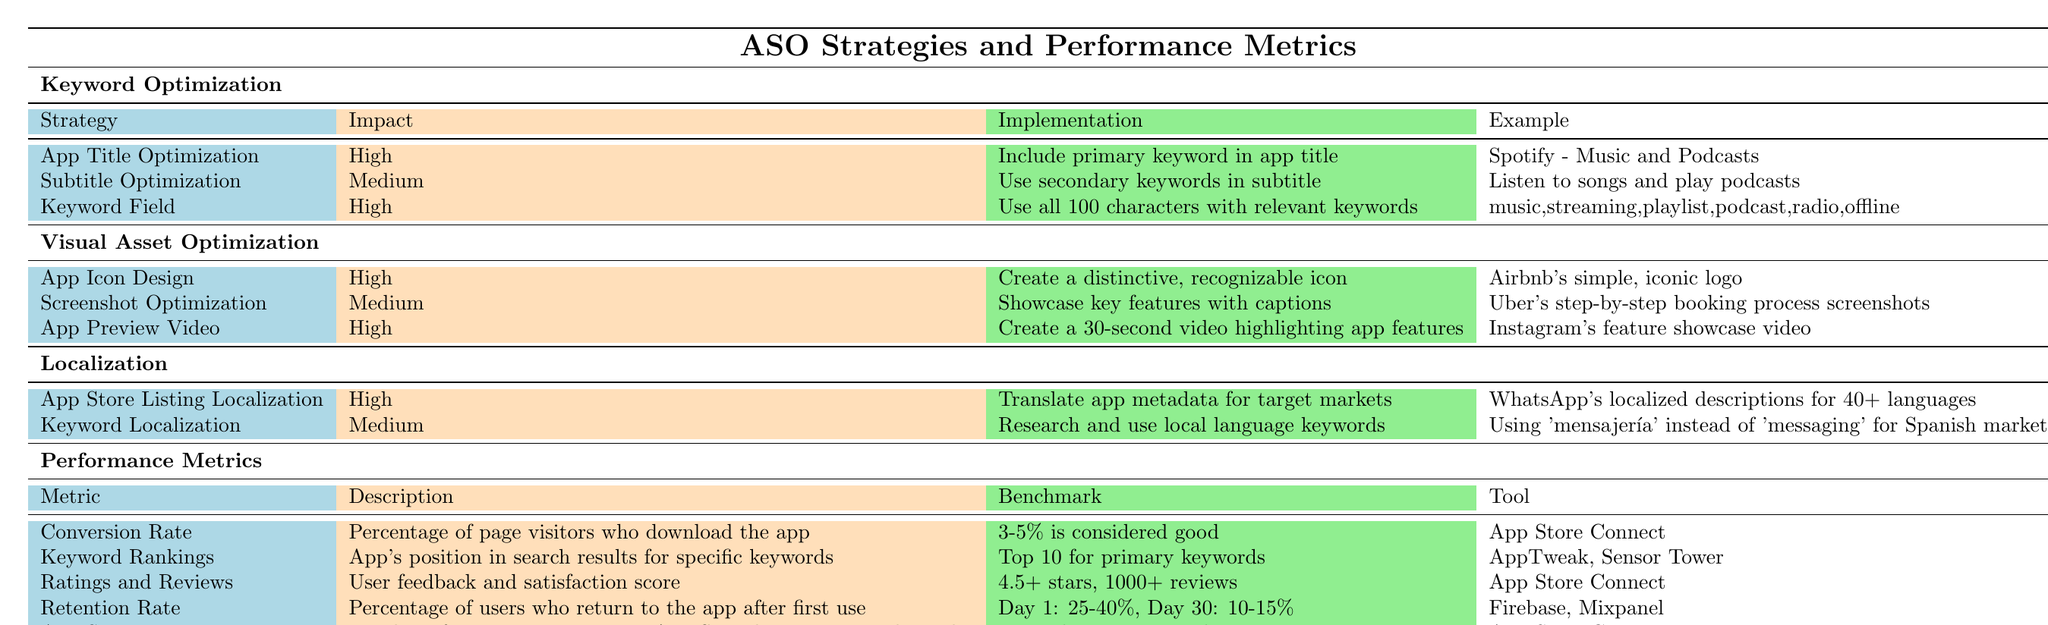What is the impact level of the "App Title Optimization" strategy? In the table, under the "Keyword Optimization" category, the row for "App Title Optimization" indicates that its impact is classified as "High."
Answer: High How many strategies are listed under the "Visual Asset Optimization" category? Looking at the "Visual Asset Optimization" category, there are three strategies mentioned: "App Icon Design," "Screenshot Optimization," and "App Preview Video."
Answer: 3 What is the benchmark for the "Ratings and Reviews" metric? The "Ratings and Reviews" metric in the Performance Metrics section states that the benchmark is "4.5+ stars, 1000+ reviews."
Answer: 4.5+ stars, 1000+ reviews Is "Keyword Localization" classified as a high impact strategy? In the Localization category, the "Keyword Localization" strategy shows an impact level of "Medium," which means it is not classified as high.
Answer: No What two tools can be used for tracking "Keyword Rankings"? The tools mentioned for tracking "Keyword Rankings" are "AppTweak" and "Sensor Tower."
Answer: AppTweak, Sensor Tower If the benchmarks for "Conversion Rate" and "Retention Rate" are considered, which has a higher acceptable range? The "Conversion Rate" benchmark is "3-5%," while the "Retention Rate" ranges from "25-40%" for Day 1. Comparing the two, "Retention Rate" has a higher range of acceptable values.
Answer: Retention Rate How does the implementation of "App Icon Design" compare in impact level to "Screenshot Optimization"? "App Icon Design" has a "High" impact level while "Screenshot Optimization" has a "Medium" impact level, thus indicating that "App Icon Design" is more impactful.
Answer: App Icon Design is more impactful What is the implementation strategy for "Keyword Field"? The table specifies that the implementation for "Keyword Field" is to "Use all 100 characters with relevant keywords."
Answer: Use all 100 characters with relevant keywords What is the total number of strategies listed in the "Keyword Optimization" category? There are three strategies listed under "Keyword Optimization": "App Title Optimization," "Subtitle Optimization," and "Keyword Field." Therefore, the total is three.
Answer: 3 What is the description associated with the "App Store Impressions" metric? In the Performance Metrics section, "App Store Impressions" is described as "Number of times app appears in App Store browse or search results."
Answer: Number of times app appears in App Store browse or search results Which ASO strategy has the most examples given? Reviewing the provided categories, both "Keyword Optimization" and "Visual Asset Optimization" have three strategies listed. However, "Localization" has only two strategies. So "Keyword Optimization" or "Visual Asset Optimization" could be considered, both containing the same number of examples.
Answer: Keyword Optimization or Visual Asset Optimization 